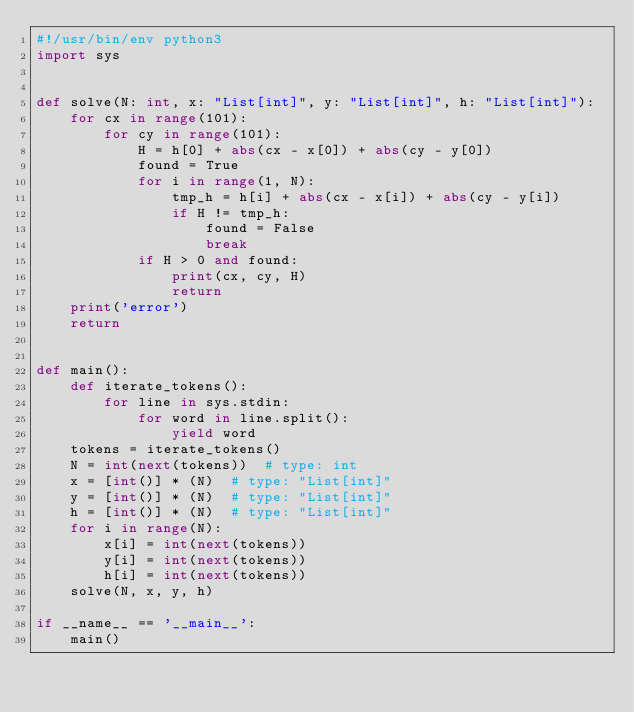<code> <loc_0><loc_0><loc_500><loc_500><_Python_>#!/usr/bin/env python3
import sys


def solve(N: int, x: "List[int]", y: "List[int]", h: "List[int]"):
    for cx in range(101):
        for cy in range(101):
            H = h[0] + abs(cx - x[0]) + abs(cy - y[0])
            found = True
            for i in range(1, N):
                tmp_h = h[i] + abs(cx - x[i]) + abs(cy - y[i])
                if H != tmp_h:
                    found = False
                    break
            if H > 0 and found:
                print(cx, cy, H)
                return
    print('error')
    return


def main():
    def iterate_tokens():
        for line in sys.stdin:
            for word in line.split():
                yield word
    tokens = iterate_tokens()
    N = int(next(tokens))  # type: int
    x = [int()] * (N)  # type: "List[int]" 
    y = [int()] * (N)  # type: "List[int]" 
    h = [int()] * (N)  # type: "List[int]" 
    for i in range(N):
        x[i] = int(next(tokens))
        y[i] = int(next(tokens))
        h[i] = int(next(tokens))
    solve(N, x, y, h)

if __name__ == '__main__':
    main()
</code> 